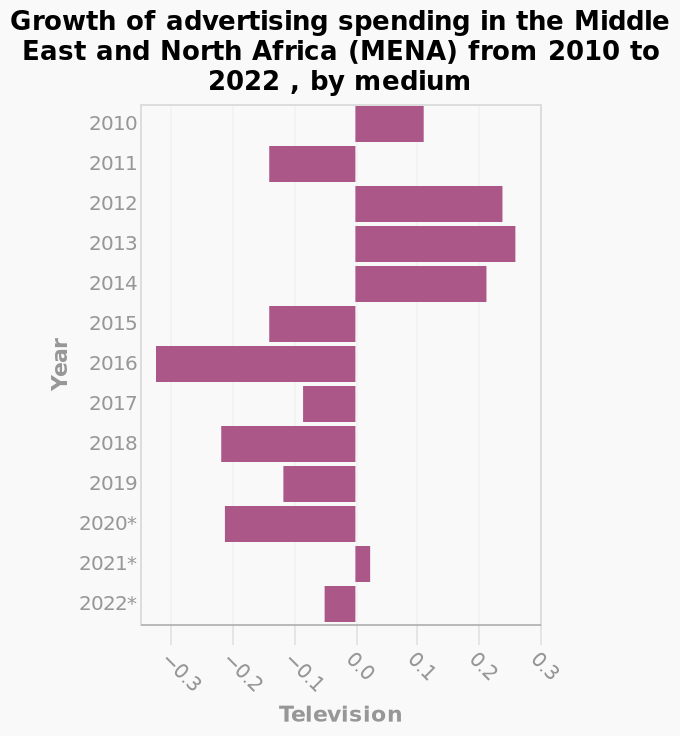<image>
What is the label on the y-axis? The y-axis is labeled "Year." Offer a thorough analysis of the image. TV advertising spending in the MENA appears to reduce in more years than it increases. TV advertising spending in the MENA reduced every year between 2015 and 2020. TV advertising spending in the MENA increased in 2021 but only by a very small amount. TV advertising spending in the MENA increased every year between 2012 to 2014. Which medium is represented on the x-axis of the bar chart? Television is represented on the x-axis of the bar chart. please enumerates aspects of the construction of the chart This is a bar chart titled Growth of advertising spending in the Middle East and North Africa (MENA) from 2010 to 2022 , by medium. Television is defined along the x-axis. There is a categorical scale starting with 2010 and ending with 2022* on the y-axis, labeled Year. Was there any pattern in TV advertising spending in the MENA between 2012 and 2014? Yes, there was a pattern in TV advertising spending in the MENA between 2012 and 2014. It increased every year during that period. 